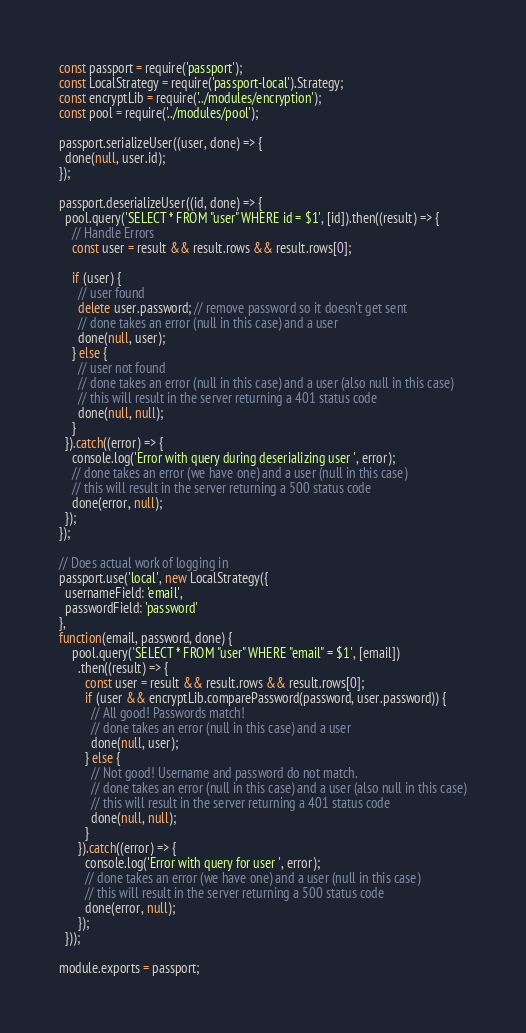<code> <loc_0><loc_0><loc_500><loc_500><_JavaScript_>const passport = require('passport');
const LocalStrategy = require('passport-local').Strategy;
const encryptLib = require('../modules/encryption');
const pool = require('../modules/pool');

passport.serializeUser((user, done) => {
  done(null, user.id);
});

passport.deserializeUser((id, done) => {
  pool.query('SELECT * FROM "user" WHERE id = $1', [id]).then((result) => {
    // Handle Errors
    const user = result && result.rows && result.rows[0];

    if (user) {
      // user found
      delete user.password; // remove password so it doesn't get sent
      // done takes an error (null in this case) and a user
      done(null, user);
    } else {
      // user not found
      // done takes an error (null in this case) and a user (also null in this case)
      // this will result in the server returning a 401 status code
      done(null, null);
    }
  }).catch((error) => {
    console.log('Error with query during deserializing user ', error);
    // done takes an error (we have one) and a user (null in this case)
    // this will result in the server returning a 500 status code
    done(error, null);
  });
});

// Does actual work of logging in
passport.use('local', new LocalStrategy({
  usernameField: 'email',
  passwordField: 'password'
},
function(email, password, done) {
    pool.query('SELECT * FROM "user" WHERE "email" = $1', [email])
      .then((result) => {
        const user = result && result.rows && result.rows[0];
        if (user && encryptLib.comparePassword(password, user.password)) {
          // All good! Passwords match!
          // done takes an error (null in this case) and a user
          done(null, user);
        } else {
          // Not good! Username and password do not match.
          // done takes an error (null in this case) and a user (also null in this case)
          // this will result in the server returning a 401 status code
          done(null, null);
        }
      }).catch((error) => {
        console.log('Error with query for user ', error);
        // done takes an error (we have one) and a user (null in this case)
        // this will result in the server returning a 500 status code
        done(error, null);
      });
  }));

module.exports = passport;
</code> 